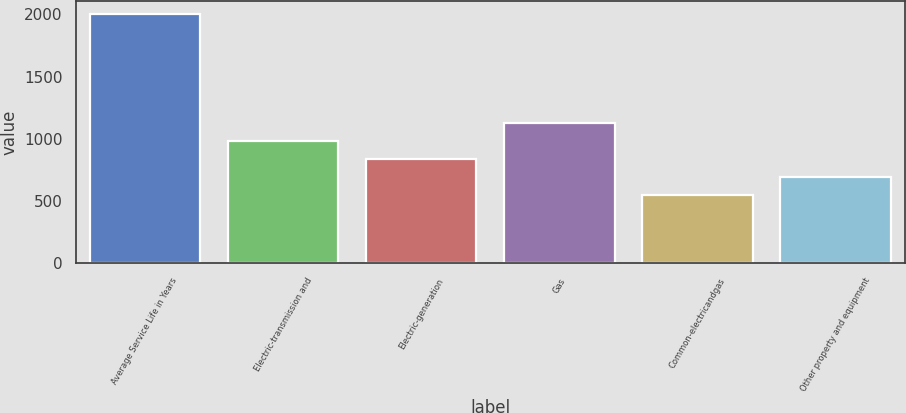Convert chart to OTSL. <chart><loc_0><loc_0><loc_500><loc_500><bar_chart><fcel>Average Service Life in Years<fcel>Electric-transmission and<fcel>Electric-generation<fcel>Gas<fcel>Common-electricandgas<fcel>Other property and equipment<nl><fcel>2004<fcel>983.4<fcel>837.6<fcel>1129.2<fcel>546<fcel>691.8<nl></chart> 